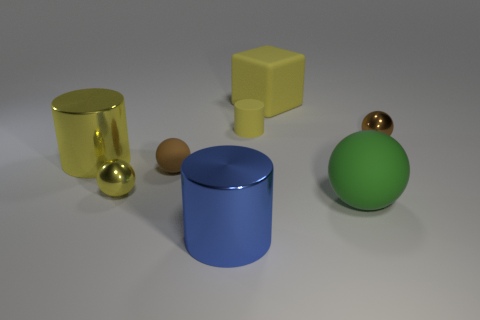Is the color of the large block the same as the tiny cylinder?
Offer a terse response. Yes. How many large blue metal objects are to the left of the tiny yellow cylinder?
Provide a succinct answer. 1. What number of things are cubes or tiny yellow metallic spheres?
Offer a terse response. 2. There is a large object that is on the left side of the big cube and behind the big green sphere; what is its shape?
Offer a terse response. Cylinder. How many big rubber balls are there?
Provide a succinct answer. 1. There is another large cylinder that is made of the same material as the large blue cylinder; what color is it?
Give a very brief answer. Yellow. Are there more metal objects than yellow matte cylinders?
Your answer should be very brief. Yes. What size is the thing that is on the right side of the big blue cylinder and left of the big yellow matte thing?
Make the answer very short. Small. What is the material of the big cylinder that is the same color as the small rubber cylinder?
Provide a short and direct response. Metal. Are there an equal number of tiny rubber objects behind the yellow rubber block and metal objects?
Your response must be concise. No. 